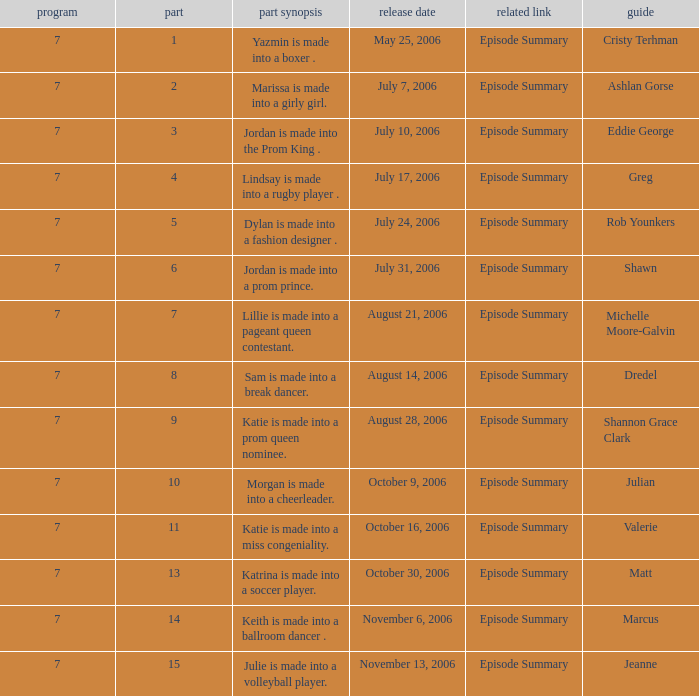How many episodes have a premier date of july 24, 2006 1.0. Could you parse the entire table as a dict? {'header': ['program', 'part', 'part synopsis', 'release date', 'related link', 'guide'], 'rows': [['7', '1', 'Yazmin is made into a boxer .', 'May 25, 2006', 'Episode Summary', 'Cristy Terhman'], ['7', '2', 'Marissa is made into a girly girl.', 'July 7, 2006', 'Episode Summary', 'Ashlan Gorse'], ['7', '3', 'Jordan is made into the Prom King .', 'July 10, 2006', 'Episode Summary', 'Eddie George'], ['7', '4', 'Lindsay is made into a rugby player .', 'July 17, 2006', 'Episode Summary', 'Greg'], ['7', '5', 'Dylan is made into a fashion designer .', 'July 24, 2006', 'Episode Summary', 'Rob Younkers'], ['7', '6', 'Jordan is made into a prom prince.', 'July 31, 2006', 'Episode Summary', 'Shawn'], ['7', '7', 'Lillie is made into a pageant queen contestant.', 'August 21, 2006', 'Episode Summary', 'Michelle Moore-Galvin'], ['7', '8', 'Sam is made into a break dancer.', 'August 14, 2006', 'Episode Summary', 'Dredel'], ['7', '9', 'Katie is made into a prom queen nominee.', 'August 28, 2006', 'Episode Summary', 'Shannon Grace Clark'], ['7', '10', 'Morgan is made into a cheerleader.', 'October 9, 2006', 'Episode Summary', 'Julian'], ['7', '11', 'Katie is made into a miss congeniality.', 'October 16, 2006', 'Episode Summary', 'Valerie'], ['7', '13', 'Katrina is made into a soccer player.', 'October 30, 2006', 'Episode Summary', 'Matt'], ['7', '14', 'Keith is made into a ballroom dancer .', 'November 6, 2006', 'Episode Summary', 'Marcus'], ['7', '15', 'Julie is made into a volleyball player.', 'November 13, 2006', 'Episode Summary', 'Jeanne']]} 